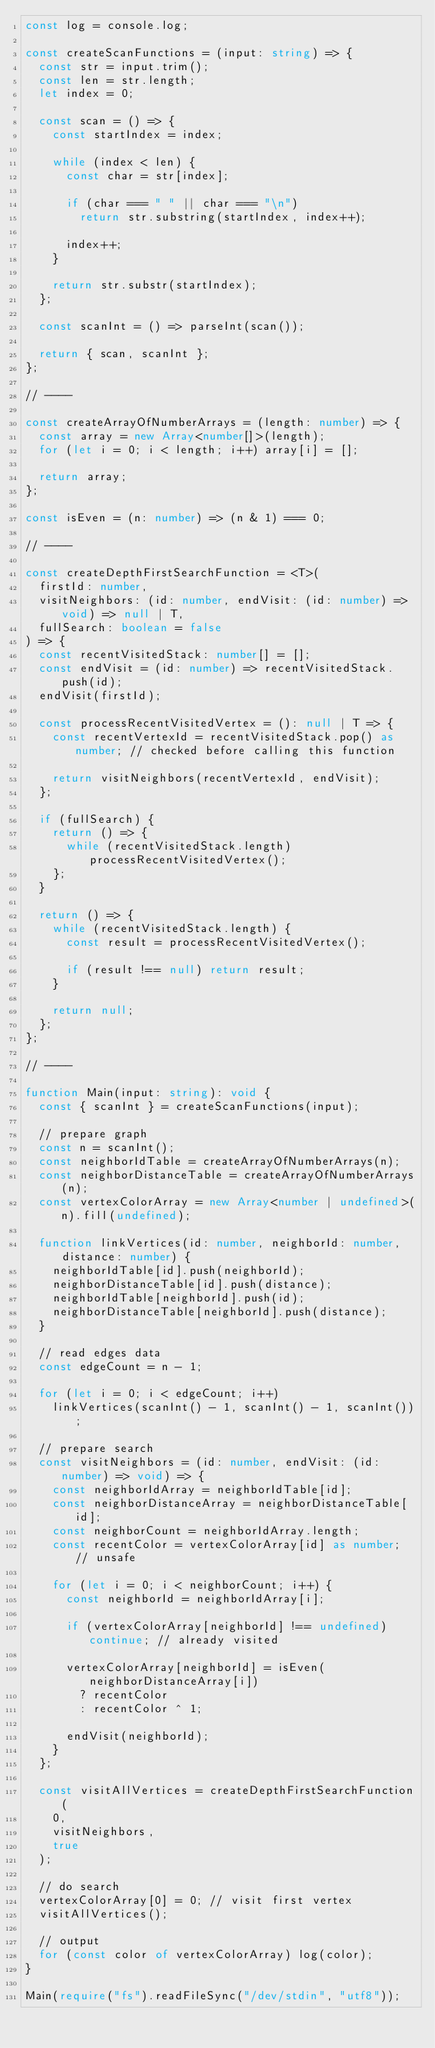Convert code to text. <code><loc_0><loc_0><loc_500><loc_500><_TypeScript_>const log = console.log;

const createScanFunctions = (input: string) => {
  const str = input.trim();
  const len = str.length;
  let index = 0;

  const scan = () => {
    const startIndex = index;

    while (index < len) {
      const char = str[index];

      if (char === " " || char === "\n")
        return str.substring(startIndex, index++);

      index++;
    }

    return str.substr(startIndex);
  };

  const scanInt = () => parseInt(scan());

  return { scan, scanInt };
};

// ----

const createArrayOfNumberArrays = (length: number) => {
  const array = new Array<number[]>(length);
  for (let i = 0; i < length; i++) array[i] = [];

  return array;
};

const isEven = (n: number) => (n & 1) === 0;

// ----

const createDepthFirstSearchFunction = <T>(
  firstId: number,
  visitNeighbors: (id: number, endVisit: (id: number) => void) => null | T,
  fullSearch: boolean = false
) => {
  const recentVisitedStack: number[] = [];
  const endVisit = (id: number) => recentVisitedStack.push(id);
  endVisit(firstId);

  const processRecentVisitedVertex = (): null | T => {
    const recentVertexId = recentVisitedStack.pop() as number; // checked before calling this function

    return visitNeighbors(recentVertexId, endVisit);
  };

  if (fullSearch) {
    return () => {
      while (recentVisitedStack.length) processRecentVisitedVertex();
    };
  }

  return () => {
    while (recentVisitedStack.length) {
      const result = processRecentVisitedVertex();

      if (result !== null) return result;
    }

    return null;
  };
};

// ----

function Main(input: string): void {
  const { scanInt } = createScanFunctions(input);

  // prepare graph
  const n = scanInt();
  const neighborIdTable = createArrayOfNumberArrays(n);
  const neighborDistanceTable = createArrayOfNumberArrays(n);
  const vertexColorArray = new Array<number | undefined>(n).fill(undefined);

  function linkVertices(id: number, neighborId: number, distance: number) {
    neighborIdTable[id].push(neighborId);
    neighborDistanceTable[id].push(distance);
    neighborIdTable[neighborId].push(id);
    neighborDistanceTable[neighborId].push(distance);
  }

  // read edges data
  const edgeCount = n - 1;

  for (let i = 0; i < edgeCount; i++)
    linkVertices(scanInt() - 1, scanInt() - 1, scanInt());

  // prepare search
  const visitNeighbors = (id: number, endVisit: (id: number) => void) => {
    const neighborIdArray = neighborIdTable[id];
    const neighborDistanceArray = neighborDistanceTable[id];
    const neighborCount = neighborIdArray.length;
    const recentColor = vertexColorArray[id] as number; // unsafe

    for (let i = 0; i < neighborCount; i++) {
      const neighborId = neighborIdArray[i];

      if (vertexColorArray[neighborId] !== undefined) continue; // already visited

      vertexColorArray[neighborId] = isEven(neighborDistanceArray[i])
        ? recentColor
        : recentColor ^ 1;

      endVisit(neighborId);
    }
  };

  const visitAllVertices = createDepthFirstSearchFunction(
    0,
    visitNeighbors,
    true
  );

  // do search
  vertexColorArray[0] = 0; // visit first vertex
  visitAllVertices();

  // output
  for (const color of vertexColorArray) log(color);
}

Main(require("fs").readFileSync("/dev/stdin", "utf8"));</code> 